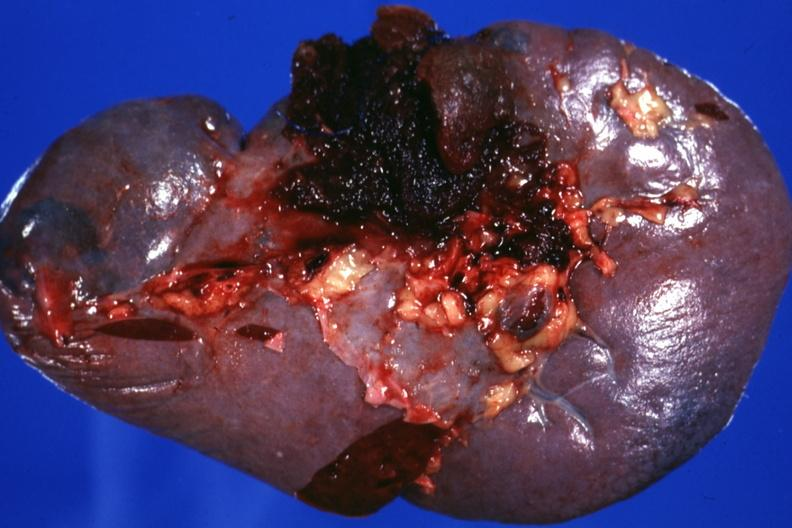does this image show close-up excellent example?
Answer the question using a single word or phrase. Yes 